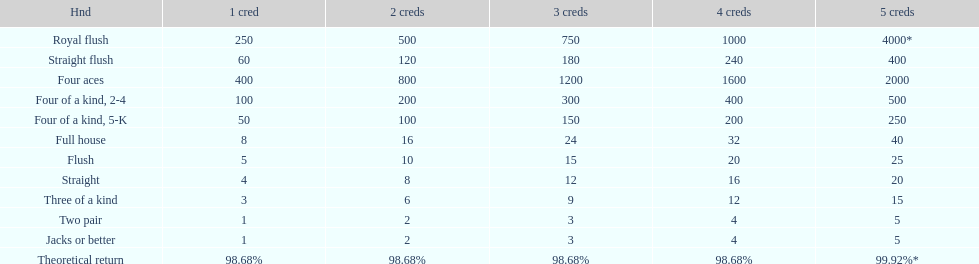Each four aces win is a multiple of what number? 400. 